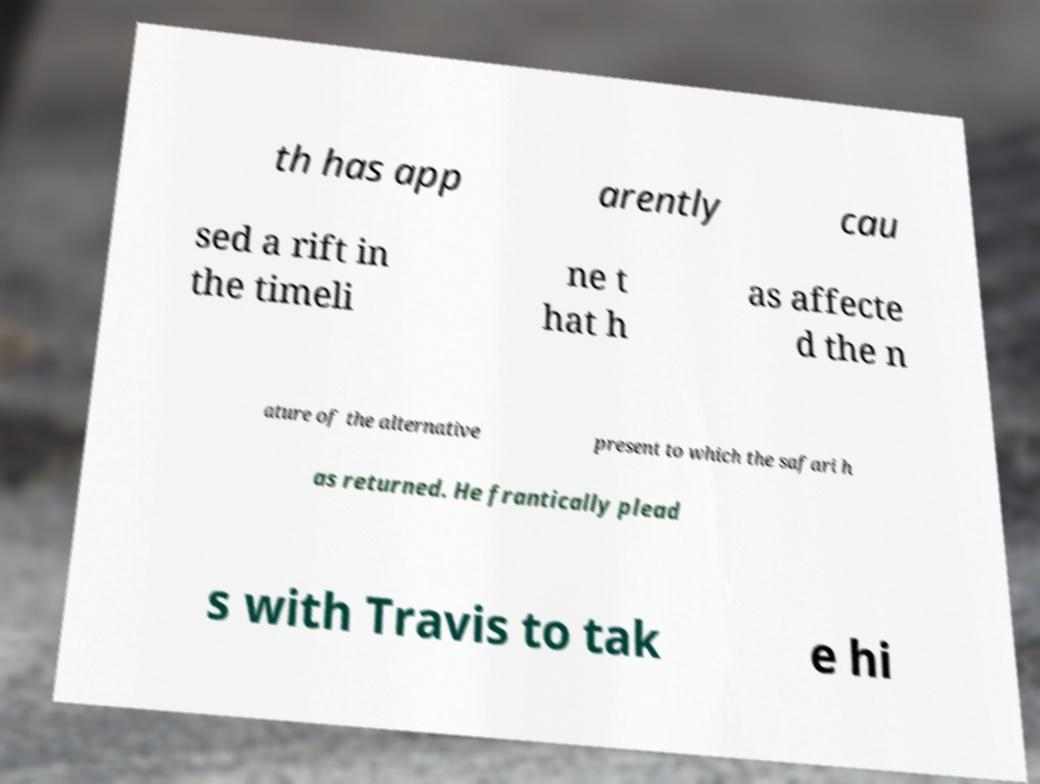I need the written content from this picture converted into text. Can you do that? th has app arently cau sed a rift in the timeli ne t hat h as affecte d the n ature of the alternative present to which the safari h as returned. He frantically plead s with Travis to tak e hi 